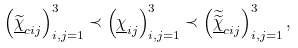Convert formula to latex. <formula><loc_0><loc_0><loc_500><loc_500>\\ \left ( \widetilde { \underline { \chi } } _ { c i j } \right ) _ { i , j = 1 } ^ { 3 } \prec \left ( \underline { \chi } _ { i j } \right ) _ { i , j = 1 } ^ { 3 } \prec \left ( \widetilde { \widetilde { \underline { \chi } } } _ { c i j } \right ) _ { i , j = 1 } ^ { 3 } , \\</formula> 